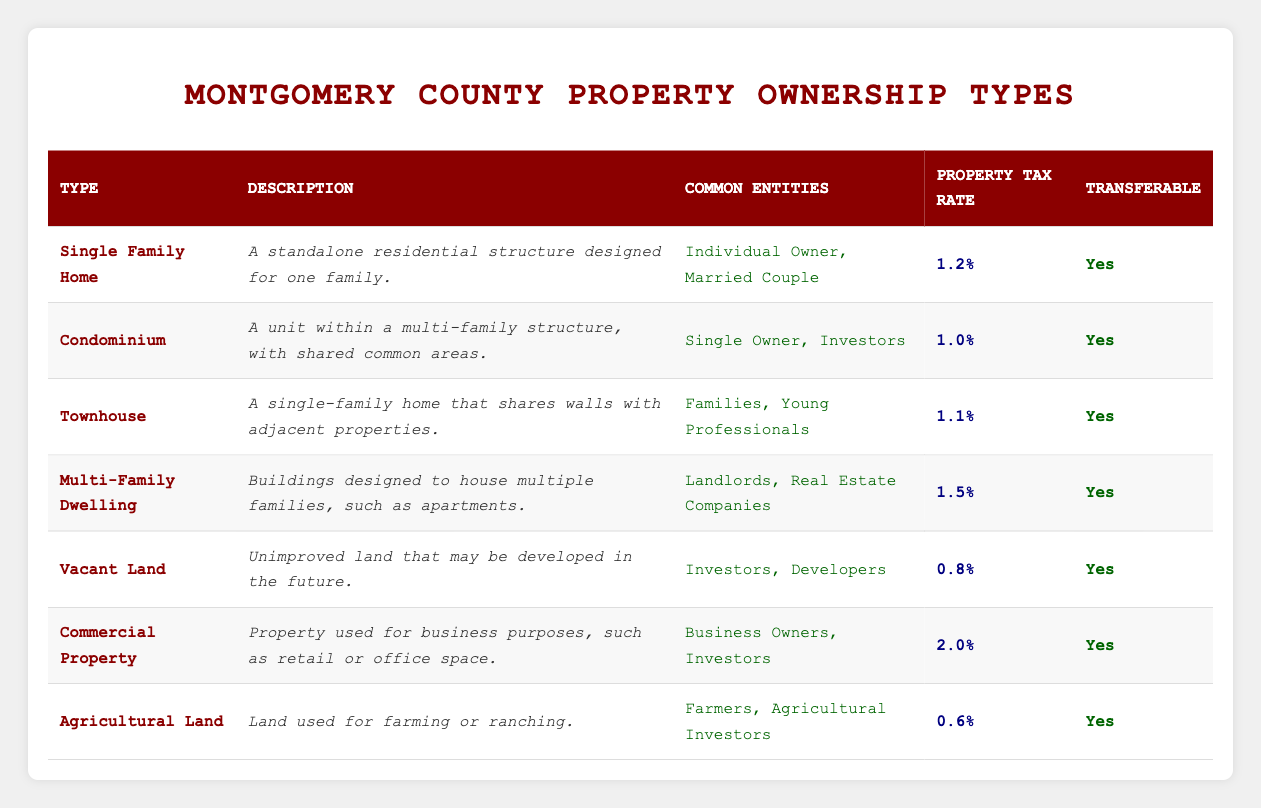What is the property tax rate for a Condominium? The property tax rate for a Condominium is listed in the table under the "Property Tax Rate" column next to its type. It shows "1.0%" for this property type.
Answer: 1.0% Which property type has the highest property tax rate? To find this, we compare the tax rates listed for each property type. The highest is "2.0%" for Commercial Property.
Answer: Commercial Property Is Agricultural Land transferable? Checking the "Transferable" column for Agricultural Land, it shows "Yes," indicating that it can be transferred.
Answer: Yes How many property types have a property tax rate of less than 1.1%? The property tax rates are 0.8% for Vacant Land and 0.6% for Agricultural Land. Therefore, there are two types with rates less than 1.1%.
Answer: 2 What is the average property tax rate of Single Family Homes, Townhouses, and Multi-Family Dwellings? The rates for these types are 1.2% (Single Family Home), 1.1% (Townhouse), and 1.5% (Multi-Family Dwelling). To calculate the average, we sum them up (1.2 + 1.1 + 1.5 = 3.8) and divide by 3. The average is 3.8 / 3 = 1.27%.
Answer: 1.27% Which property types are primarily owned by Investors? Looking under "Common Entities," we identify that both Condominiums and Vacant Land have Investors listed as common owners, so these are the types owned by Investors.
Answer: Condominium, Vacant Land Are Townhouses designed for single families? The description for Townhouses states that they are "a single-family home that shares walls with adjacent properties," confirming that they are designed for single families.
Answer: Yes What is the property tax rate difference between Agricultural Land and Commercial Property? Agricultural Land has a property tax rate of 0.6% and Commercial Property has a tax rate of 2.0%. To find the difference, we subtract 0.6 from 2.0, resulting in a difference of 1.4%.
Answer: 1.4% 